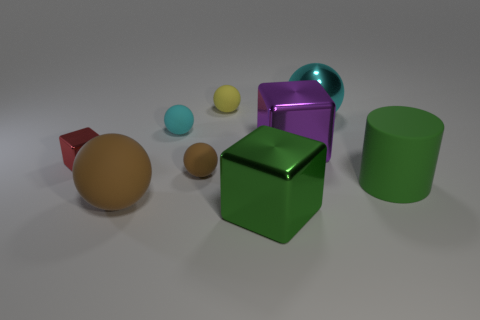Which objects in the picture look like they have a texture that's different from the others? The two balls at the front appear to have a smoother, shinier surface compared to the more matte finish on the other objects, giving them a distinct texture. 